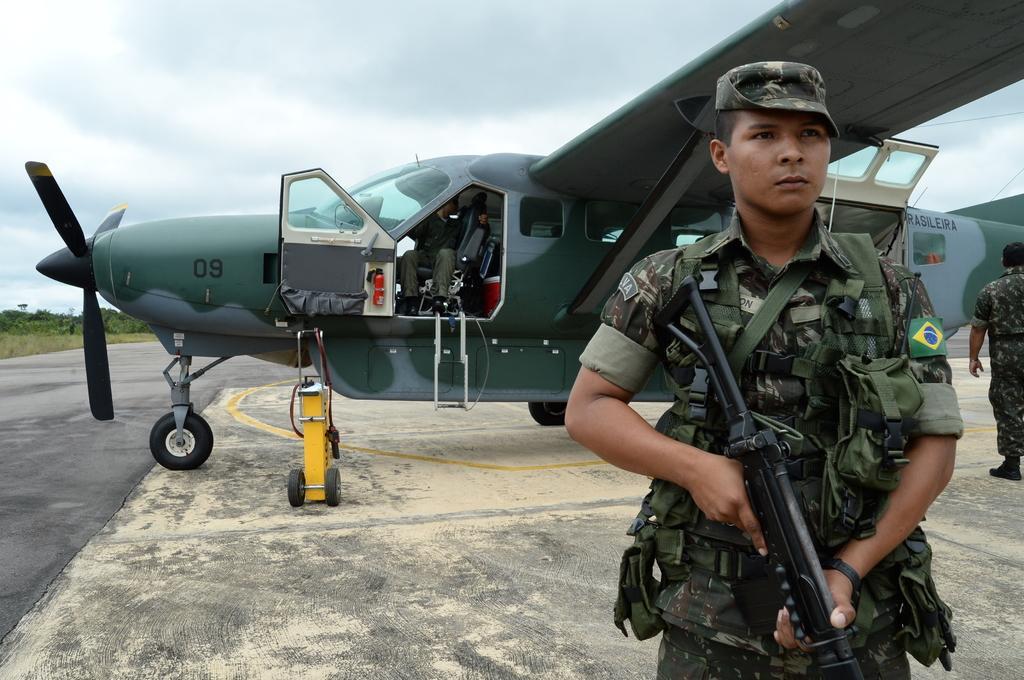Could you give a brief overview of what you see in this image? There is a person sitting on a seat of a aircraft, which is on the runway, near two persons who are standing on the runway. In the background, there are trees, there is a grass on ground, there are clouds in the sky. 